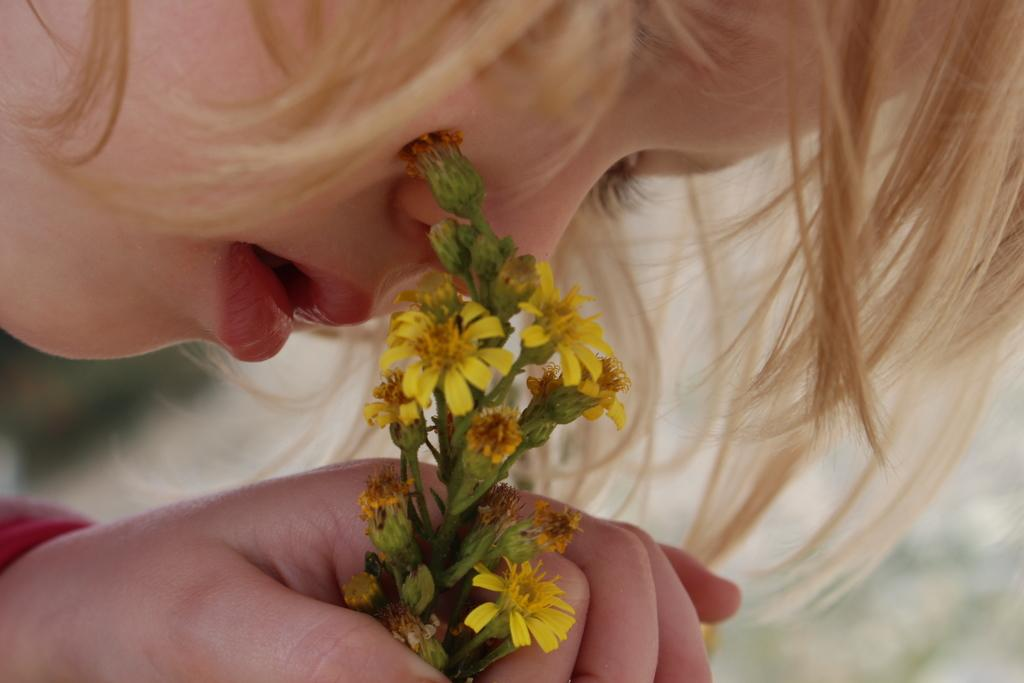Who is the main subject in the image? There is a girl in the image. What is the girl holding in the image? The girl is holding flowers. Can you describe the girl's hair in the image? The girl's hair is visible on the right side of the image. What is the girl wearing in the image? The girl is wearing a red dress. What shape is the marble that the girl is playing with in the image? There is no marble present in the image, and the girl is not playing with any marble. 